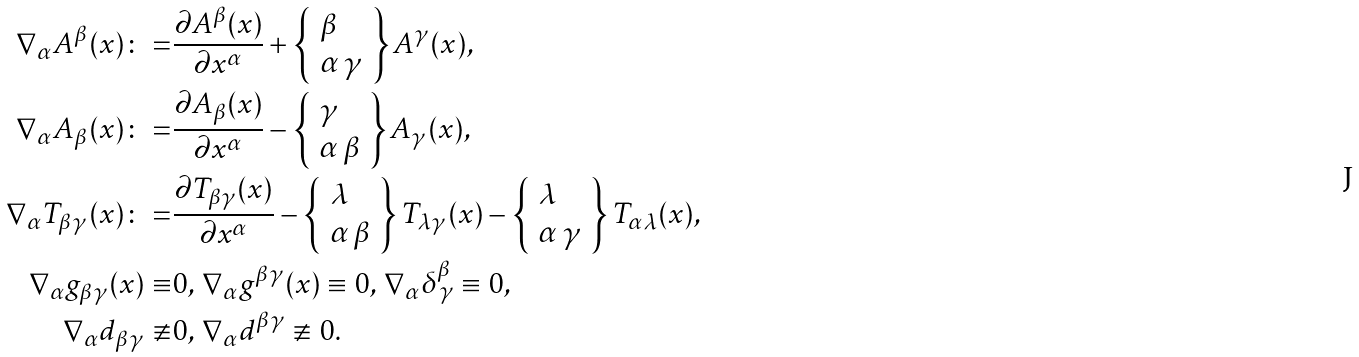<formula> <loc_0><loc_0><loc_500><loc_500>\nabla _ { \alpha } A ^ { \beta } ( x ) \colon = & \frac { \partial A ^ { \beta } ( x ) } { \partial x ^ { \alpha } } + \left \{ \begin{array} { l } \beta \\ \alpha \, \gamma \end{array} \right \} A ^ { \gamma } ( x ) , \\ \nabla _ { \alpha } A _ { \beta } ( x ) \colon = & \frac { \partial A _ { \beta } ( x ) } { \partial x ^ { \alpha } } - \left \{ \begin{array} { l } \gamma \\ \alpha \, \beta \end{array} \right \} A _ { \gamma } ( x ) , \\ \nabla _ { \alpha } T _ { \beta \gamma } ( x ) \colon = & \frac { \partial T _ { \beta \gamma } ( x ) } { \partial x ^ { \alpha } } - \left \{ \begin{array} { l } \lambda \\ \alpha \, \beta \end{array} \right \} T _ { \lambda \gamma } ( x ) - \left \{ \begin{array} { l } \lambda \\ \alpha \, \gamma \end{array} \right \} T _ { \alpha \lambda } ( x ) , \\ \nabla _ { \alpha } g _ { \beta \gamma } ( x ) \equiv & 0 , \, \nabla _ { \alpha } g ^ { \beta \gamma } ( x ) \equiv 0 , \, \nabla _ { \alpha } \delta ^ { \beta } _ { \, \gamma } \equiv 0 , \\ \nabla _ { \alpha } d _ { \beta \gamma } \not \equiv & 0 , \, \nabla _ { \alpha } d ^ { \beta \gamma } \not \equiv 0 .</formula> 